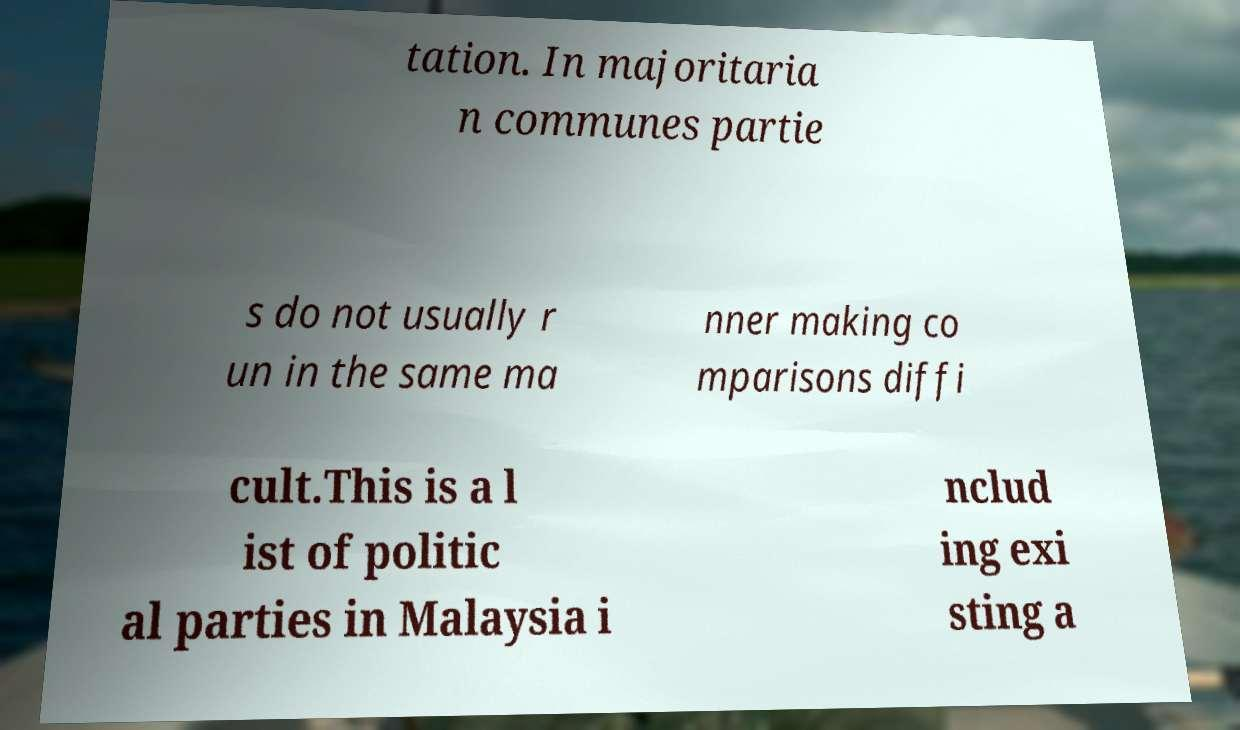There's text embedded in this image that I need extracted. Can you transcribe it verbatim? tation. In majoritaria n communes partie s do not usually r un in the same ma nner making co mparisons diffi cult.This is a l ist of politic al parties in Malaysia i nclud ing exi sting a 